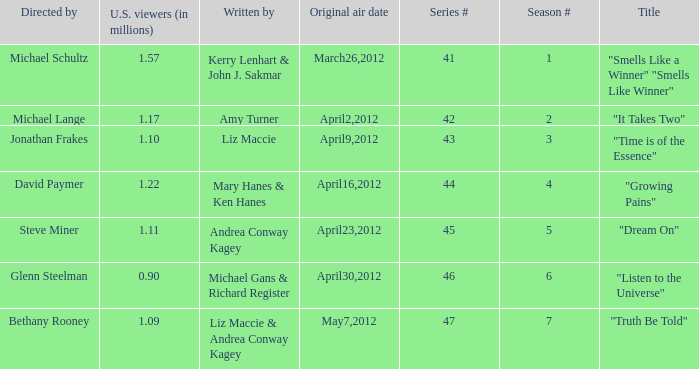How many millions of viewers did the episode written by Andrea Conway Kagey? 1.11. 